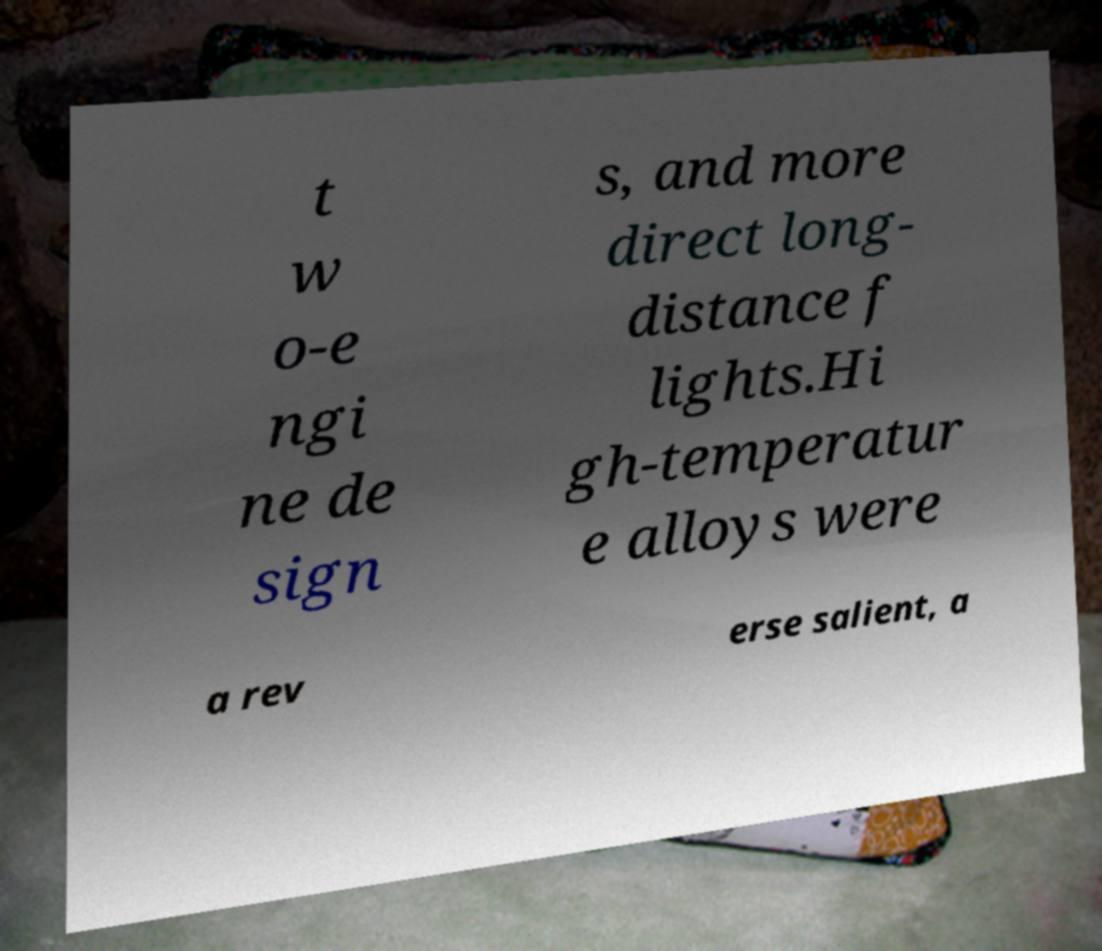What messages or text are displayed in this image? I need them in a readable, typed format. t w o-e ngi ne de sign s, and more direct long- distance f lights.Hi gh-temperatur e alloys were a rev erse salient, a 